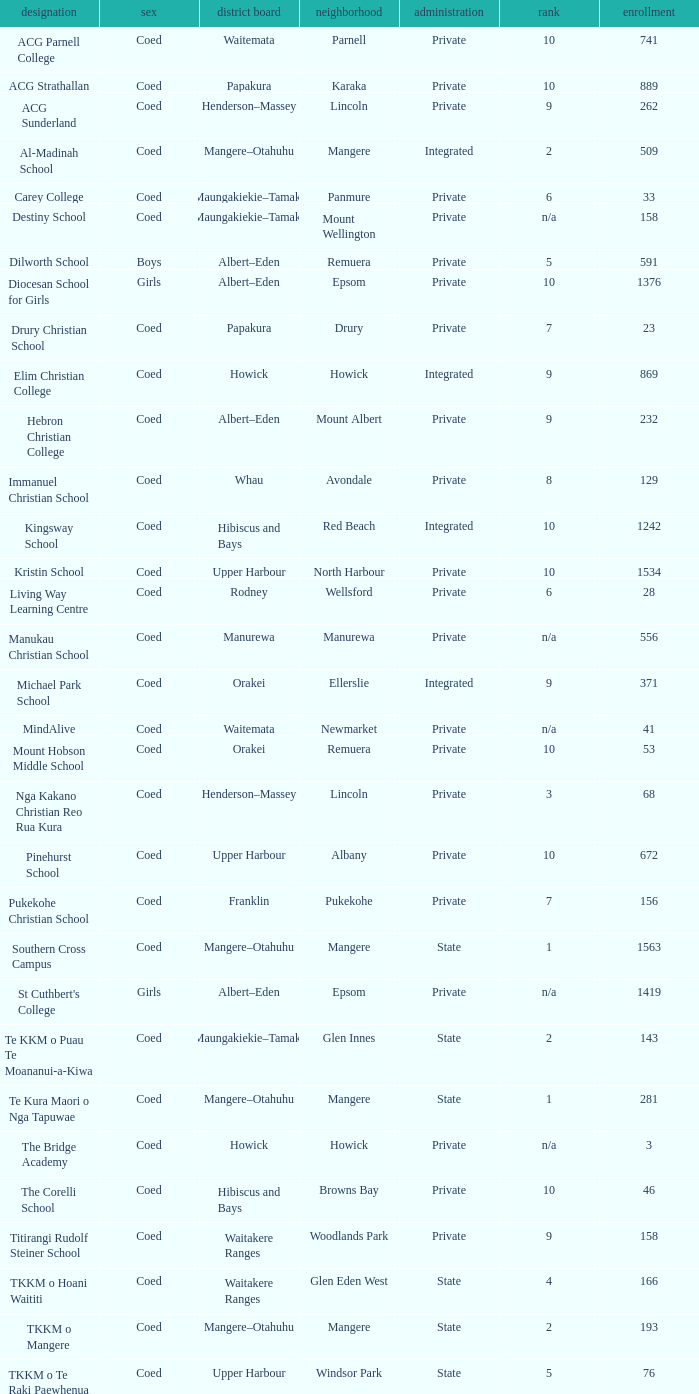What name shows as private authority and hibiscus and bays local board ? The Corelli School. 